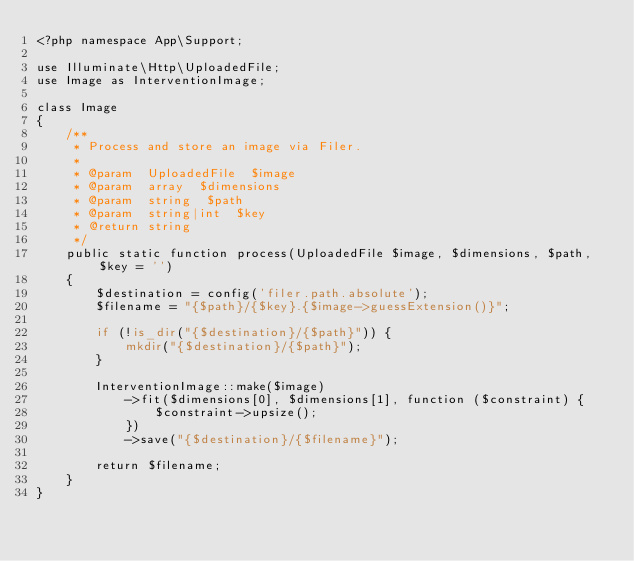<code> <loc_0><loc_0><loc_500><loc_500><_PHP_><?php namespace App\Support;

use Illuminate\Http\UploadedFile;
use Image as InterventionImage;

class Image
{
    /**
     * Process and store an image via Filer.
     *
     * @param  UploadedFile  $image
     * @param  array  $dimensions
     * @param  string  $path
     * @param  string|int  $key
     * @return string
     */
    public static function process(UploadedFile $image, $dimensions, $path, $key = '')
    {
        $destination = config('filer.path.absolute');
        $filename = "{$path}/{$key}.{$image->guessExtension()}";

        if (!is_dir("{$destination}/{$path}")) {
            mkdir("{$destination}/{$path}");
        }

        InterventionImage::make($image)
            ->fit($dimensions[0], $dimensions[1], function ($constraint) {
                $constraint->upsize();
            })
            ->save("{$destination}/{$filename}");

        return $filename;
    }
}
</code> 